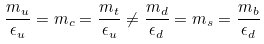<formula> <loc_0><loc_0><loc_500><loc_500>\frac { m _ { u } } { \epsilon _ { u } } = m _ { c } = \frac { m _ { t } } { \epsilon _ { u } } \neq \frac { m _ { d } } { \epsilon _ { d } } = m _ { s } = \frac { m _ { b } } { \epsilon _ { d } }</formula> 